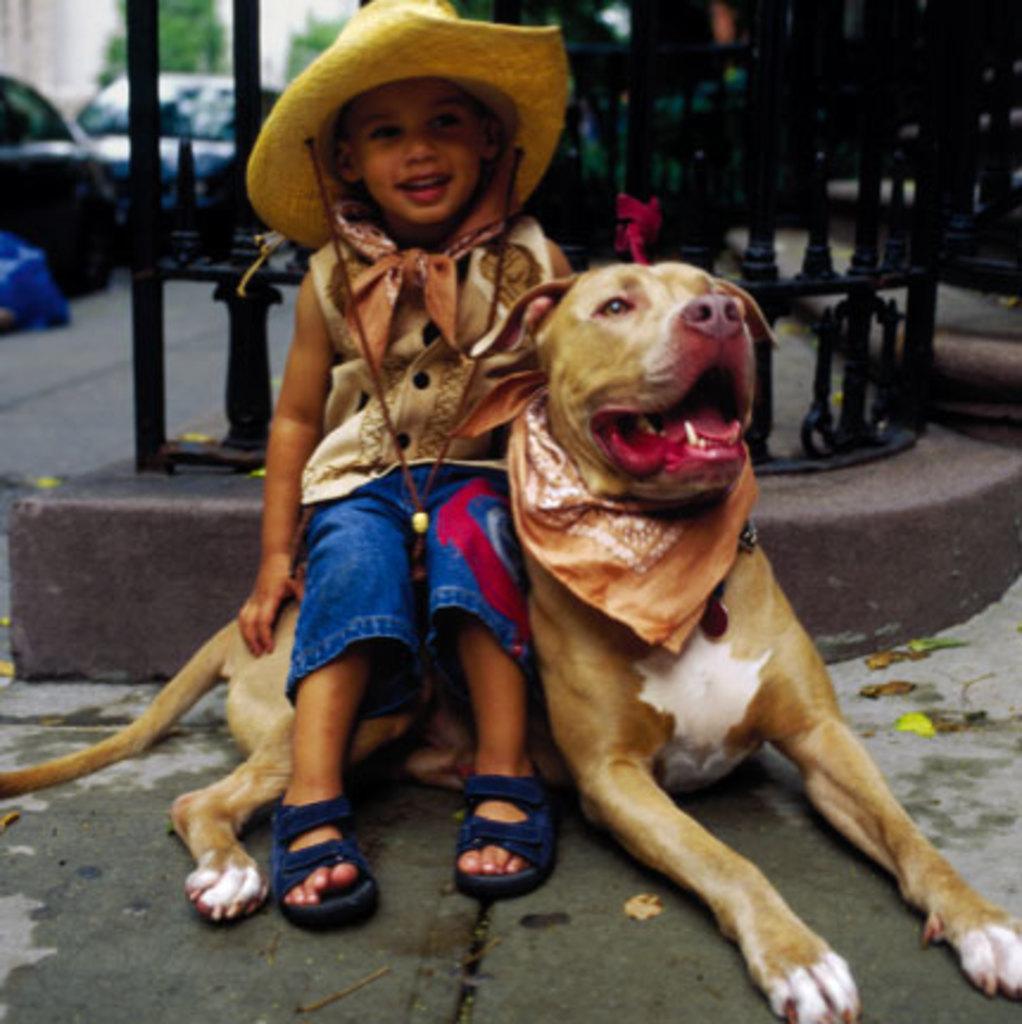Describe this image in one or two sentences. In this picture we can see a kid who is sitting on the dog. She wear a cap. On the background we can see some vehicles and this is road. 